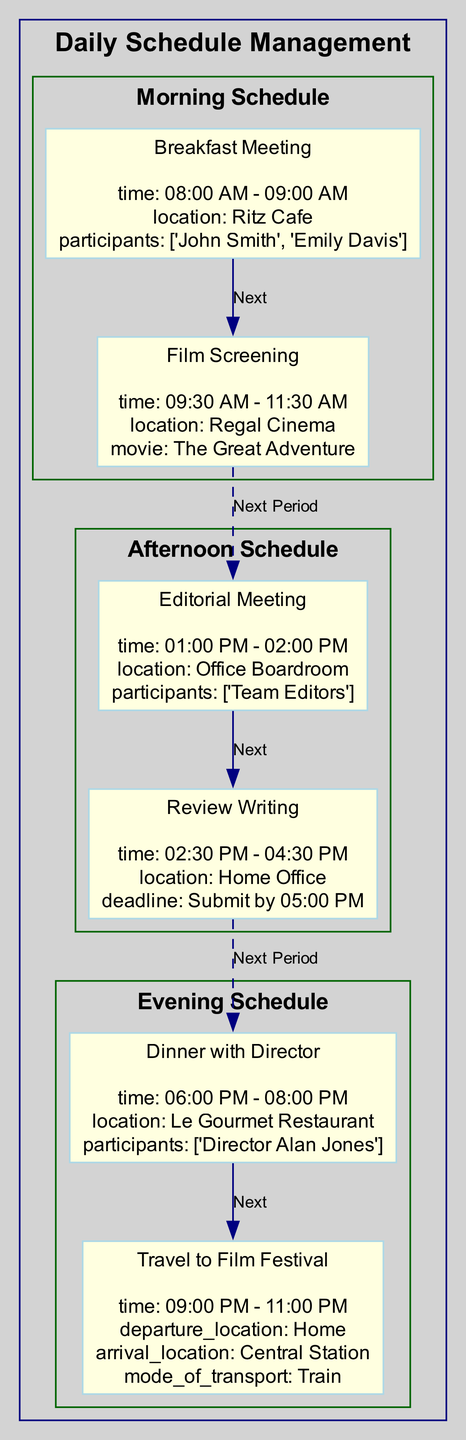What is the time of the Breakfast Meeting? The diagram indicates that the Breakfast Meeting takes place from 08:00 AM to 09:00 AM, as displayed in the details for that specific task.
Answer: 08:00 AM - 09:00 AM How many tasks are there in the Afternoon Schedule? By examining the Afternoon schedule section, it is clear that there are two tasks listed: Editorial Meeting and Review Writing. Thus, the count of tasks is two.
Answer: 2 What is the mode of transport for the Travel to Film Festival task? The Travel to Film Festival task section specifies the mode of transport as a "Train" in its details. This is an explicit detail given in the diagram.
Answer: Train Which task has a deadline to be submitted by 05:00 PM? The Review Writing task is highlighted with a detail specifying a submission deadline of 05:00 PM, as indicated in its details section in the Afternoon Schedule.
Answer: Review Writing What is the location of the Dinner with Director task? Referring to the Dinner with Director task in the Evening Schedule, it is located at "Le Gourmet Restaurant" as specifically mentioned in the details of that task.
Answer: Le Gourmet Restaurant What are the times that connect the morning to the afternoon schedule? The last task in the morning schedule is the Film Screening, ending at 11:30 AM, and the first task in the afternoon schedule is the Editorial Meeting, starting at 01:00 PM. The connection is created by the time gap between these tasks.
Answer: 11:30 AM to 01:00 PM Which task follows the Review Writing in the Afternoon Schedule? After looking through the tasks in the Afternoon schedule, it can be confirmed that there are no additional tasks following the Review Writing, as it is the last task for that period. Therefore, there is no successor task.
Answer: None In which location does the Film Screening take place? The Film Screening task details explicitly mention that it takes place at "Regal Cinema", which is clearly stated in the task overview within the diagram.
Answer: Regal Cinema What is the overview title for the evening schedule? The evening schedule overview, as indicated in the diagram, is noted as "Evening Schedule." This title encapsulates all evening tasks that follow in that section.
Answer: Evening Schedule 